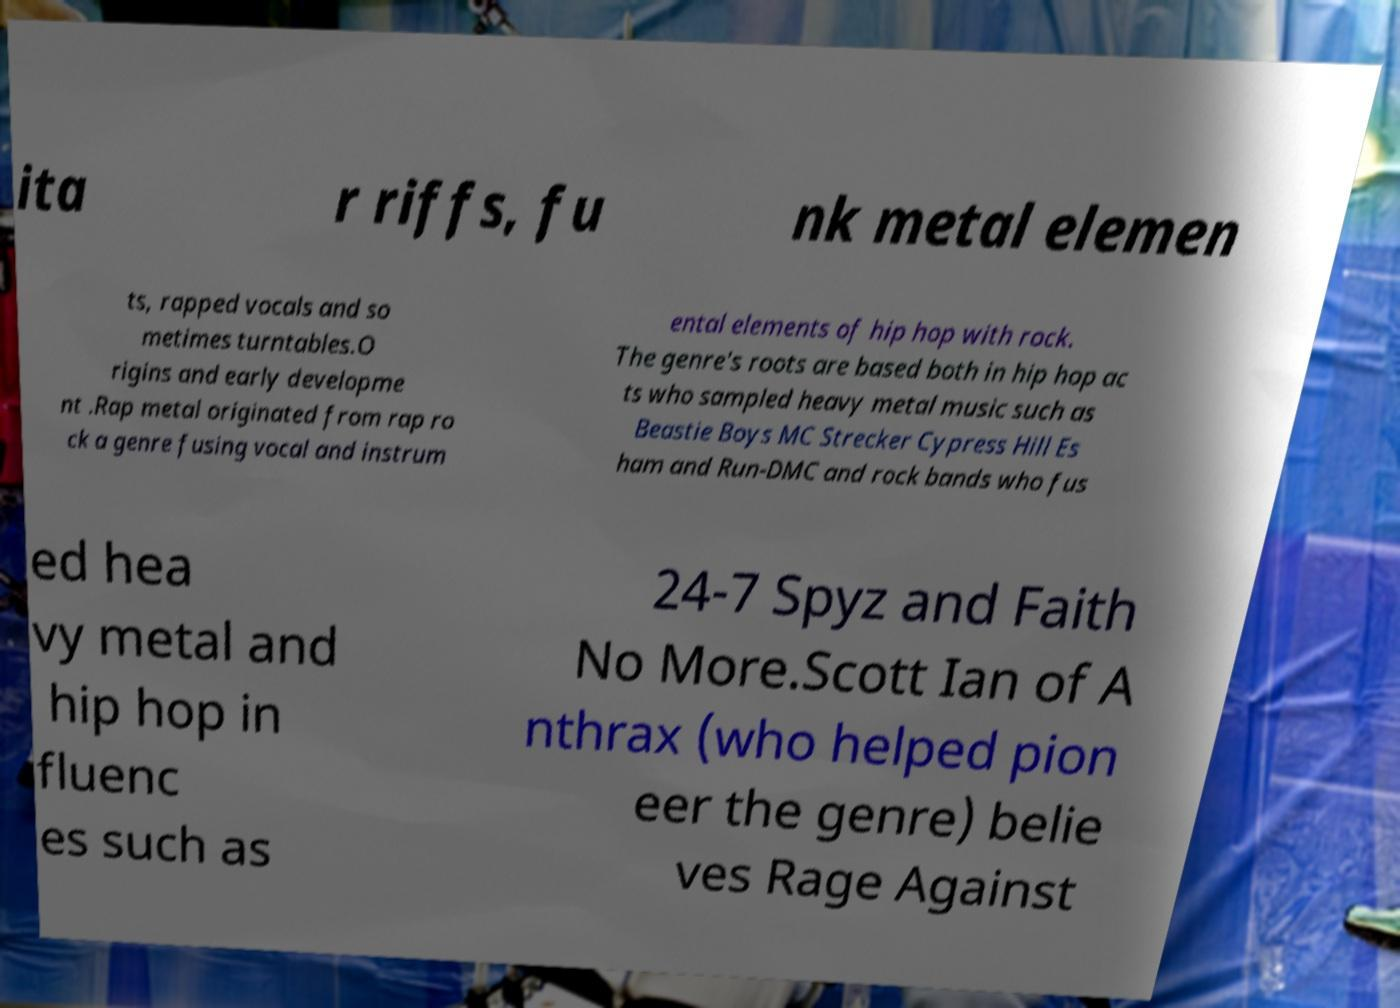There's text embedded in this image that I need extracted. Can you transcribe it verbatim? ita r riffs, fu nk metal elemen ts, rapped vocals and so metimes turntables.O rigins and early developme nt .Rap metal originated from rap ro ck a genre fusing vocal and instrum ental elements of hip hop with rock. The genre's roots are based both in hip hop ac ts who sampled heavy metal music such as Beastie Boys MC Strecker Cypress Hill Es ham and Run-DMC and rock bands who fus ed hea vy metal and hip hop in fluenc es such as 24-7 Spyz and Faith No More.Scott Ian of A nthrax (who helped pion eer the genre) belie ves Rage Against 